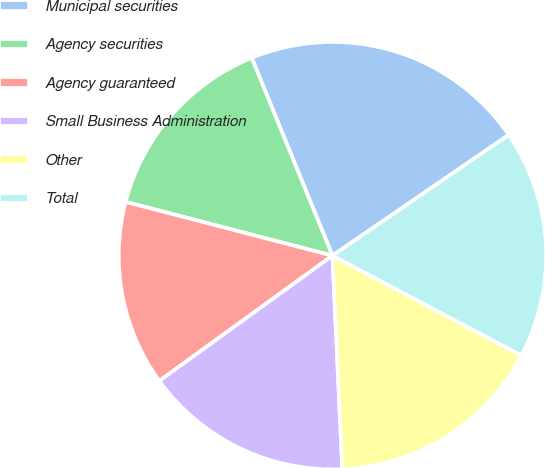Convert chart to OTSL. <chart><loc_0><loc_0><loc_500><loc_500><pie_chart><fcel>Municipal securities<fcel>Agency securities<fcel>Agency guaranteed<fcel>Small Business Administration<fcel>Other<fcel>Total<nl><fcel>21.61%<fcel>14.78%<fcel>14.02%<fcel>15.77%<fcel>16.53%<fcel>17.29%<nl></chart> 